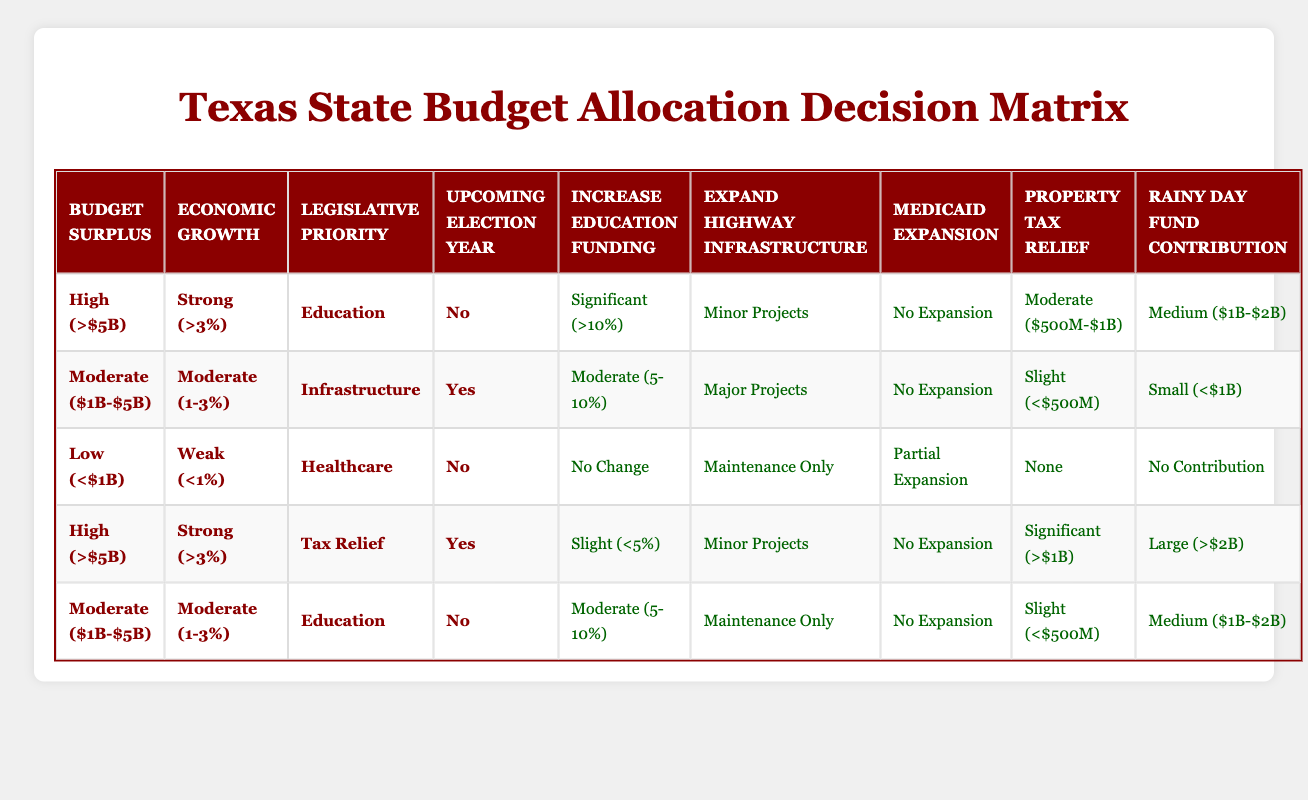What actions are suggested when there is a high budget surplus, strong economic growth, and a legislative priority of education with no upcoming election year? According to the table, the actions for these conditions are: Increase Education Funding - Significant (>10%), Expand Highway Infrastructure - Minor Projects, Medicaid Expansion - No Expansion, Property Tax Relief - Moderate ($500M-$1B), Rainy Day Fund Contribution - Medium ($1B-$2B).
Answer: Significant (>10%), Minor Projects, No Expansion, Moderate ($500M-$1B), Medium ($1B-$2B) Under what conditions is there a recommendation for significant property tax relief? The table indicates that significant property tax relief is recommended when the budget surplus is high, economic growth is strong, the legislative priority is tax relief, and there is an upcoming election year.
Answer: High budget surplus, strong economic growth, tax relief priority, upcoming election year Is there any recommendation for Medicaid expansion when the budget surplus is low and the economic growth is weak with healthcare as the legislative priority? Yes, the table shows that under these conditions, the recommendation is for partial expansion of Medicaid.
Answer: Yes What is the maximum action allowed for expanding highway infrastructure with moderate budget surplus, moderate economic growth, infrastructure priority, and an upcoming election year? The conditions point to major projects as the action for expanding highway infrastructure in this situation, according to the rules provided.
Answer: Major Projects What actions are suggested for a low budget surplus and weak economic growth when healthcare is prioritized and there is no upcoming election year? The actions suggested are: Increase Education Funding - No Change, Expand Highway Infrastructure - Maintenance Only, Medicaid Expansion - Partial Expansion, Property Tax Relief - None, Rainy Day Fund Contribution - No Contribution.
Answer: No Change, Maintenance Only, Partial Expansion, None, No Contribution If the budget surplus is moderate and the legislative priority is education without an upcoming election year, what is the recommendation for the Rainy Day Fund Contribution? The recommended action for the Rainy Day Fund Contribution under these conditions is medium ($1B-$2B), based on the corresponding rule in the table.
Answer: Medium ($1B-$2B) What is the difference in the recommended increase in education funding between the scenarios of a high budget surplus with education priority and a moderate budget surplus with education priority? For the high budget surplus with an education priority, the recommendation is significant (>10%), while for the moderate budget surplus the recommendation is moderate (5-10%). Hence, the difference is: significant (>10%) - moderate (5-10%) = more than 5%.
Answer: More than 5% Is there a scenario in the table where there is no change recommended for education funding? Yes, when the budget surplus is low, economic growth is weak, healthcare is the legislative priority, and there is no upcoming election, the recommendation for education funding is no change.
Answer: Yes 